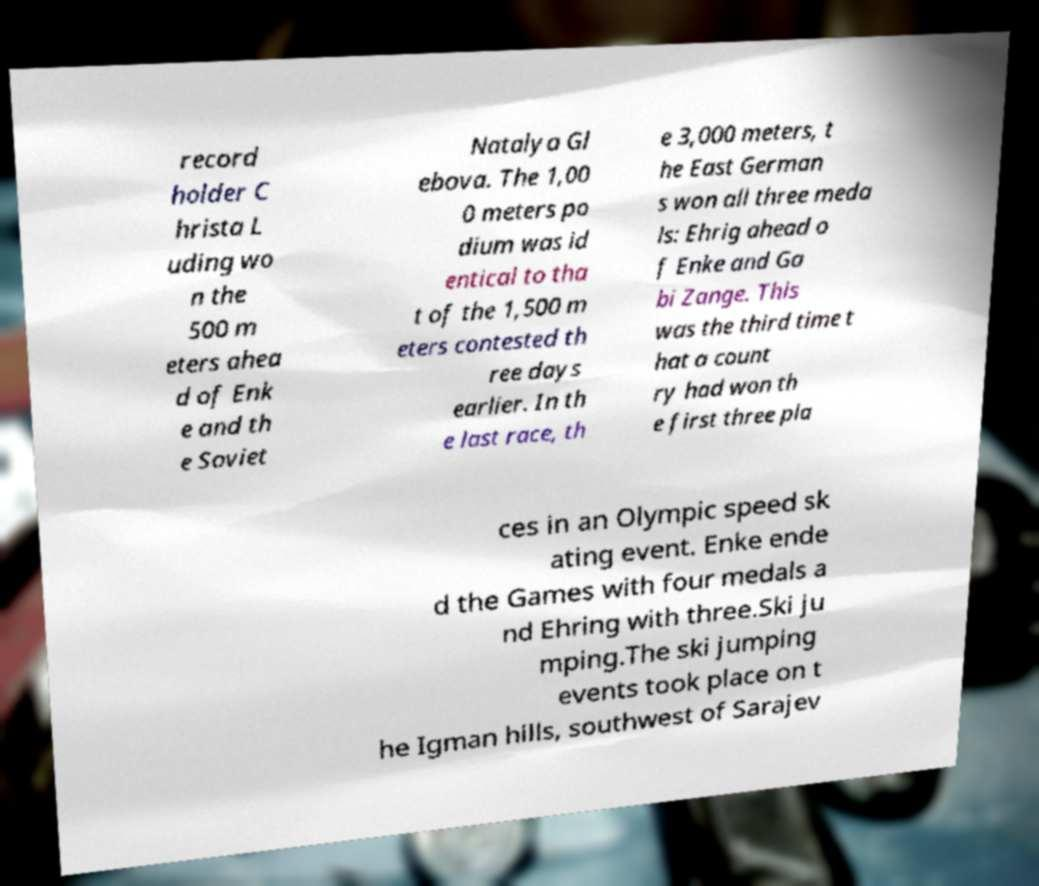Could you extract and type out the text from this image? record holder C hrista L uding wo n the 500 m eters ahea d of Enk e and th e Soviet Natalya Gl ebova. The 1,00 0 meters po dium was id entical to tha t of the 1,500 m eters contested th ree days earlier. In th e last race, th e 3,000 meters, t he East German s won all three meda ls: Ehrig ahead o f Enke and Ga bi Zange. This was the third time t hat a count ry had won th e first three pla ces in an Olympic speed sk ating event. Enke ende d the Games with four medals a nd Ehring with three.Ski ju mping.The ski jumping events took place on t he Igman hills, southwest of Sarajev 